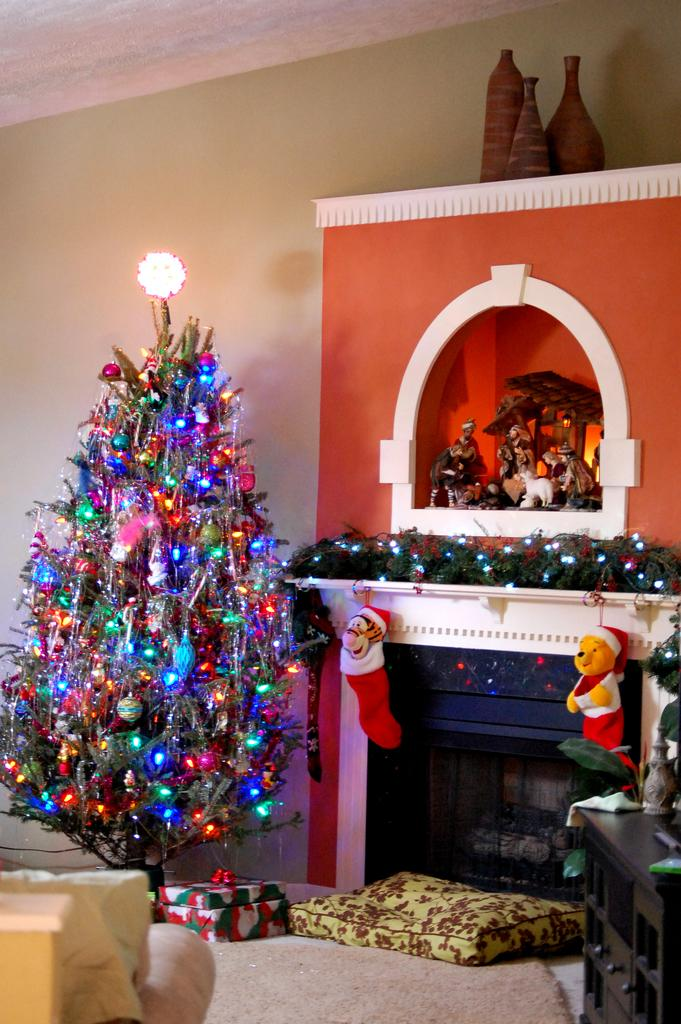What is located on the right side of the image? There is a table on the right side of the image. What is on the left side of the image? There is a tree on the left side of the image. How is the tree decorated? The tree is decorated with lights. What can be seen in the background of the image? There are objects visible in the background of the image, and there is a wall in the background as well. Where is the bottle placed on the stage in the image? There is no bottle or stage present in the image. How old is the baby sitting on the wall in the image? There is no baby present in the image. 